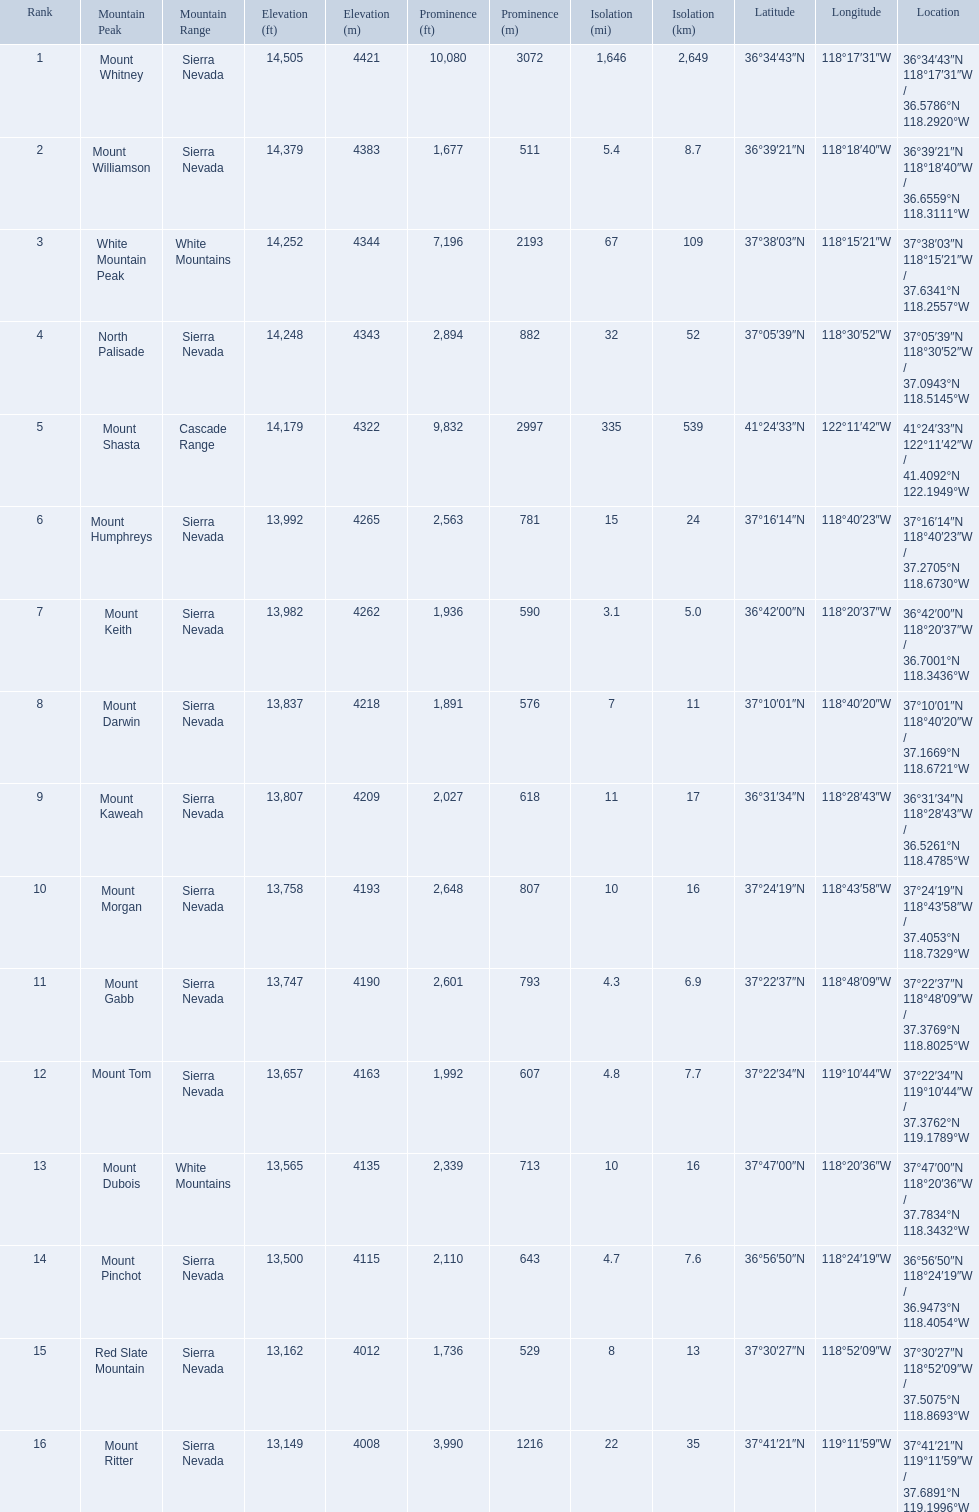Which are the mountain peaks? Mount Whitney, Mount Williamson, White Mountain Peak, North Palisade, Mount Shasta, Mount Humphreys, Mount Keith, Mount Darwin, Mount Kaweah, Mount Morgan, Mount Gabb, Mount Tom, Mount Dubois, Mount Pinchot, Red Slate Mountain, Mount Ritter. Of these, which is in the cascade range? Mount Shasta. 